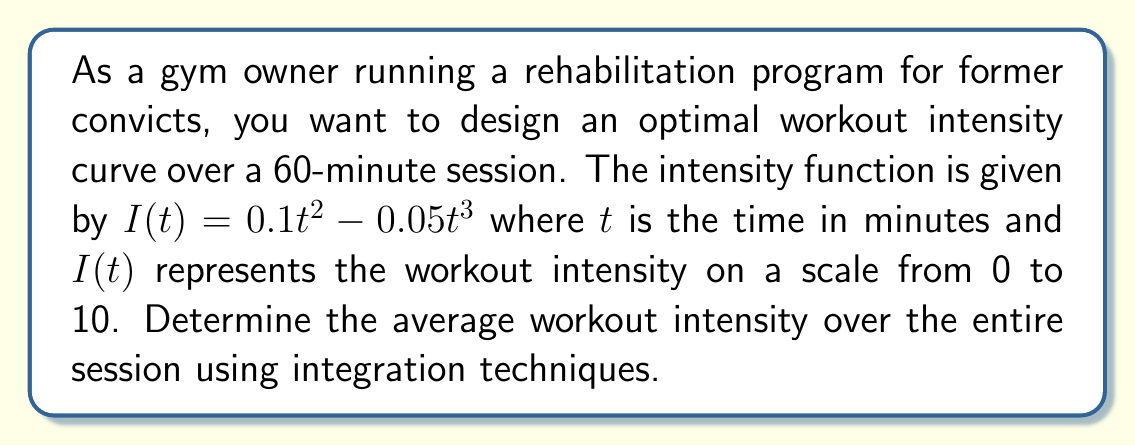Can you answer this question? To find the average workout intensity over the entire session, we need to use the concept of the definite integral and the Mean Value Theorem for Integrals.

1. First, we need to calculate the total area under the intensity curve over the 60-minute session. This is done by integrating the intensity function from 0 to 60:

   $$\int_0^{60} I(t) dt = \int_0^{60} (0.1t^2 - 0.05t^3) dt$$

2. Let's integrate this function:
   
   $$\int_0^{60} (0.1t^2 - 0.05t^3) dt = [0.1 \cdot \frac{t^3}{3} - 0.05 \cdot \frac{t^4}{4}]_0^{60}$$

3. Evaluate the integral:
   
   $$= (0.1 \cdot \frac{60^3}{3} - 0.05 \cdot \frac{60^4}{4}) - (0.1 \cdot \frac{0^3}{3} - 0.05 \cdot \frac{0^4}{4})$$
   $$= (7200 - 5400000) - (0 - 0) = 1800$$

4. Now, to find the average intensity, we divide the total area by the time interval:

   Average Intensity = $\frac{\text{Total Area}}{\text{Time Interval}} = \frac{1800}{60} = 30$

Therefore, the average workout intensity over the 60-minute session is 30.
Answer: The average workout intensity over the 60-minute session is 30. 